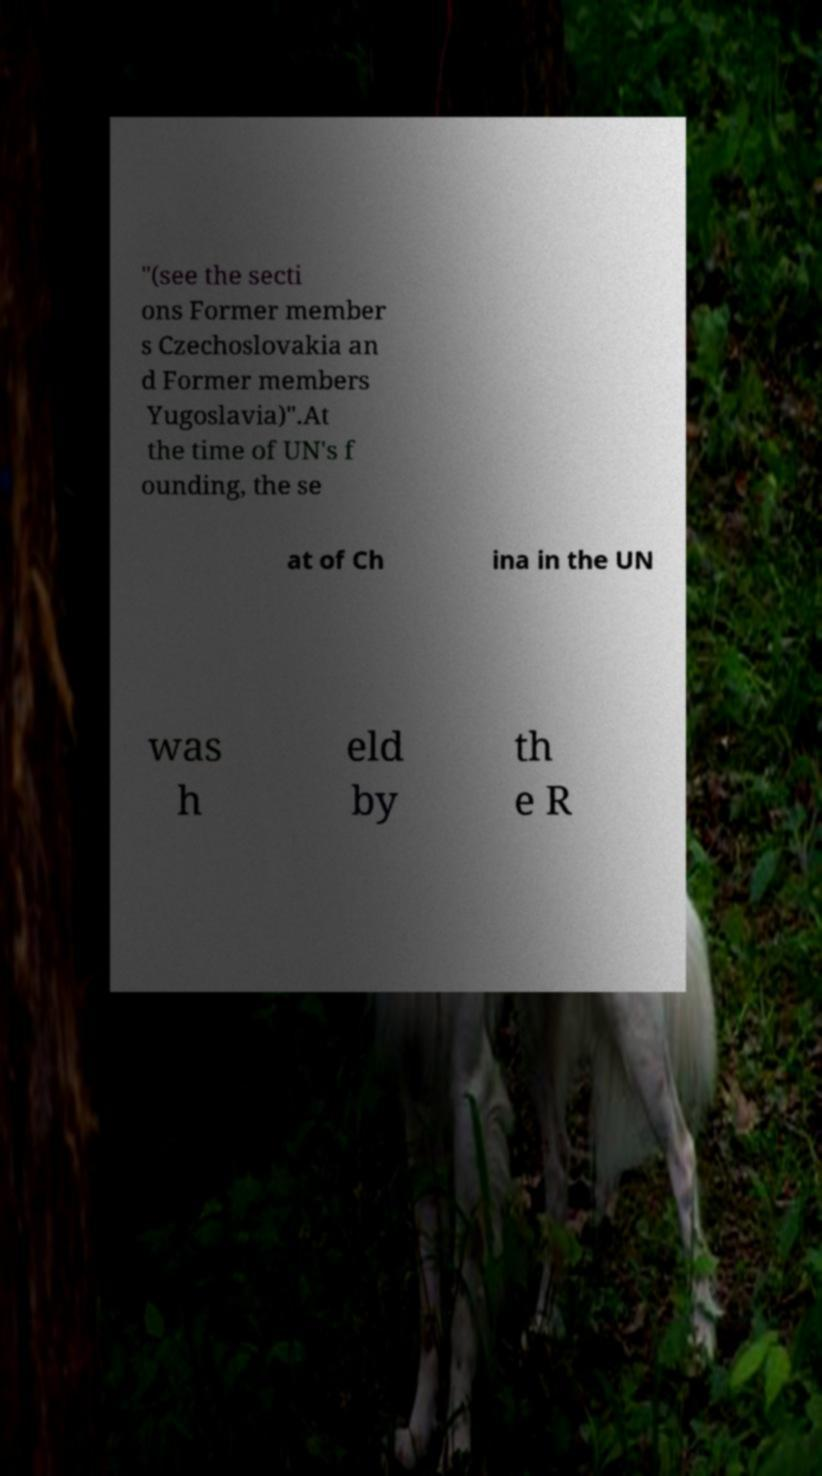Please read and relay the text visible in this image. What does it say? "(see the secti ons Former member s Czechoslovakia an d Former members Yugoslavia)".At the time of UN's f ounding, the se at of Ch ina in the UN was h eld by th e R 